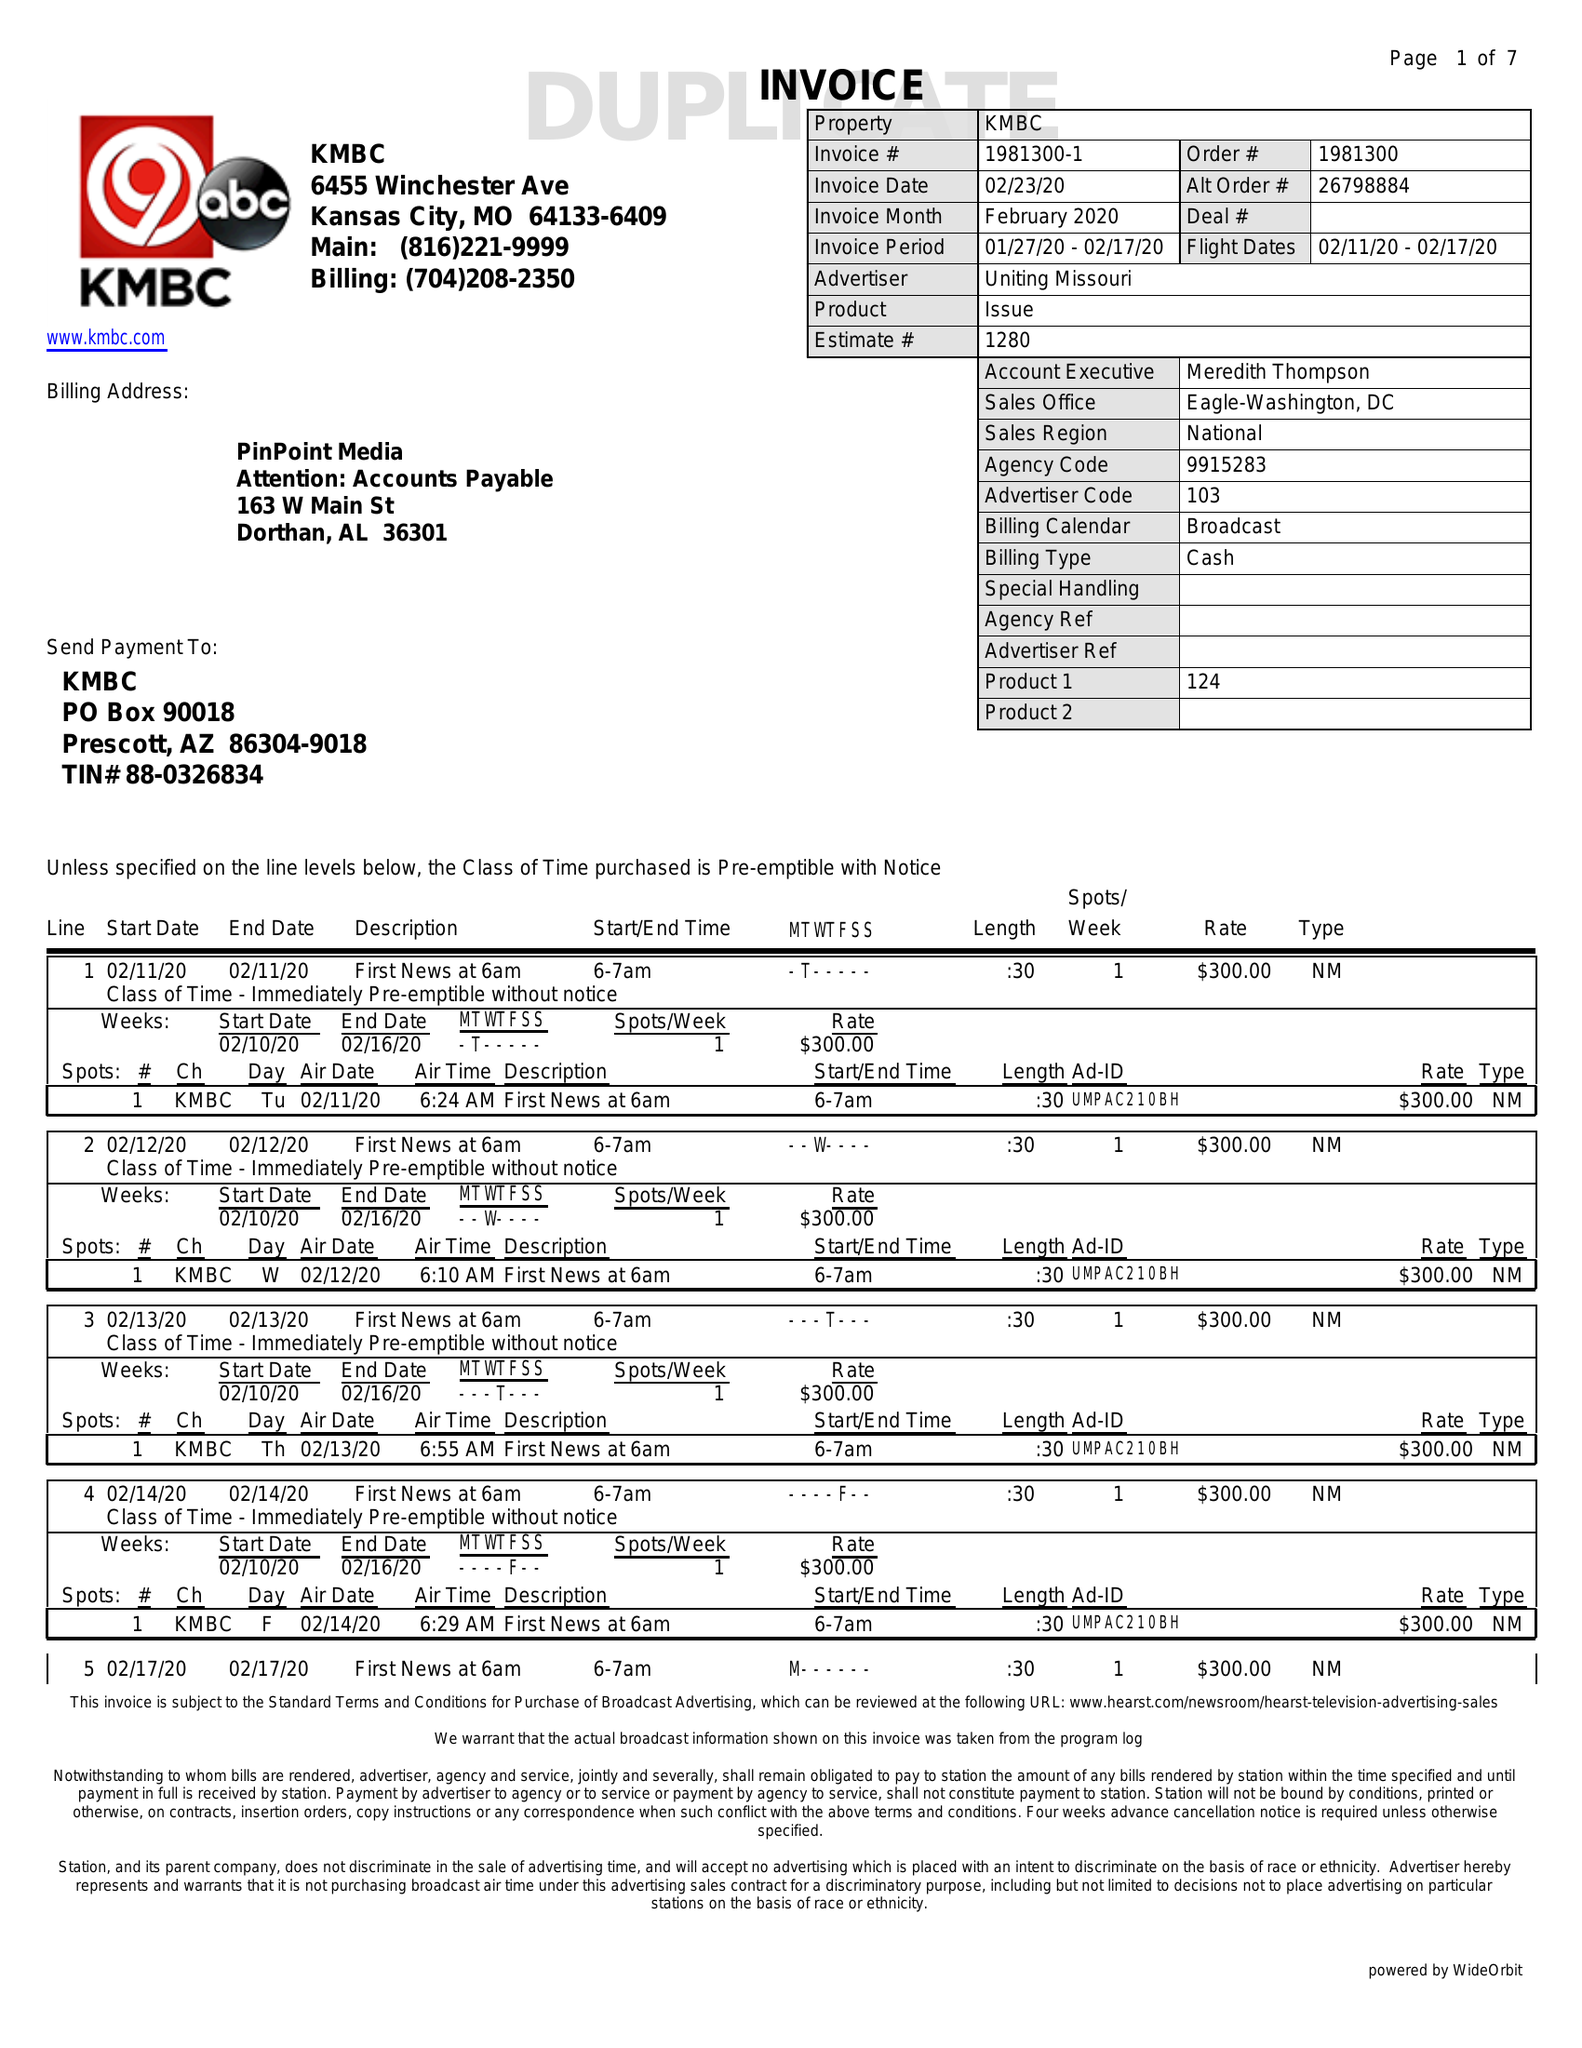What is the value for the contract_num?
Answer the question using a single word or phrase. 1981300 